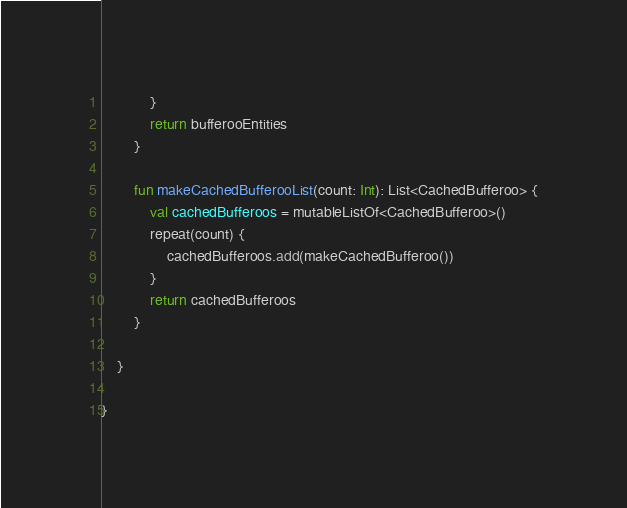<code> <loc_0><loc_0><loc_500><loc_500><_Kotlin_>            }
            return bufferooEntities
        }

        fun makeCachedBufferooList(count: Int): List<CachedBufferoo> {
            val cachedBufferoos = mutableListOf<CachedBufferoo>()
            repeat(count) {
                cachedBufferoos.add(makeCachedBufferoo())
            }
            return cachedBufferoos
        }

    }

}</code> 